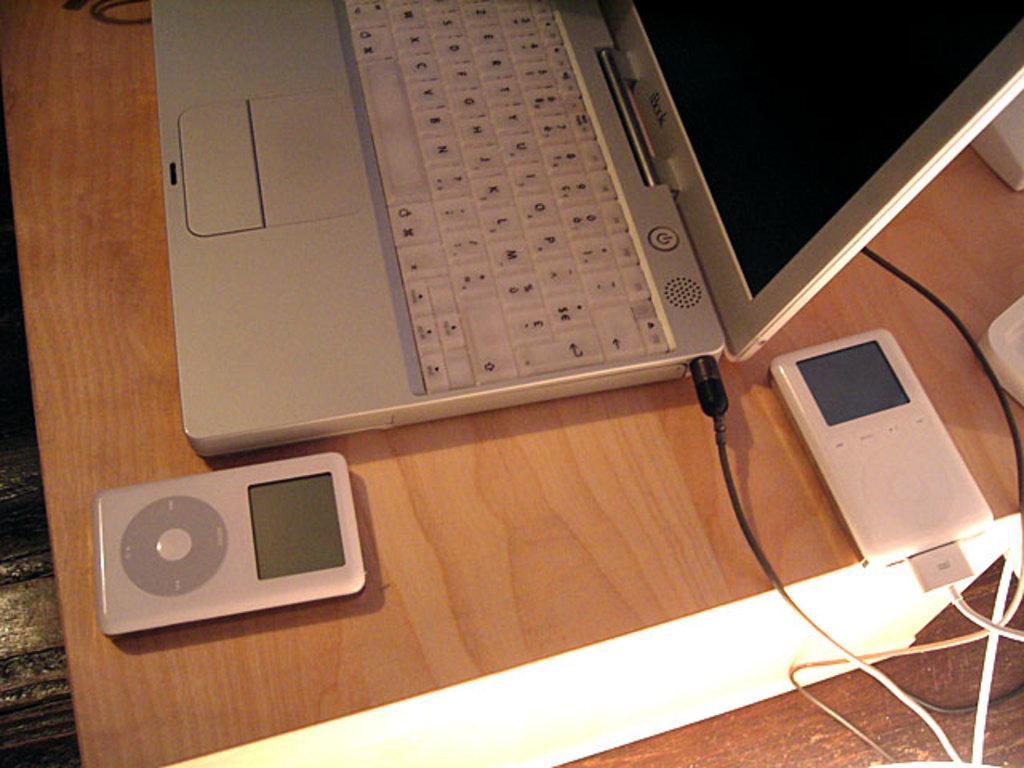Could you give a brief overview of what you see in this image? In this image we can see a laptop, wires and some electronic devices on the table. 